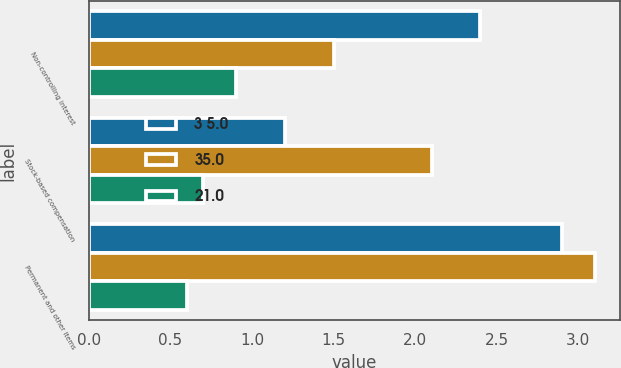Convert chart to OTSL. <chart><loc_0><loc_0><loc_500><loc_500><stacked_bar_chart><ecel><fcel>Non-controlling interest<fcel>Stock-based compensation<fcel>Permanent and other items<nl><fcel>3 5.0<fcel>2.4<fcel>1.2<fcel>2.9<nl><fcel>35.0<fcel>1.5<fcel>2.1<fcel>3.1<nl><fcel>21.0<fcel>0.9<fcel>0.7<fcel>0.6<nl></chart> 